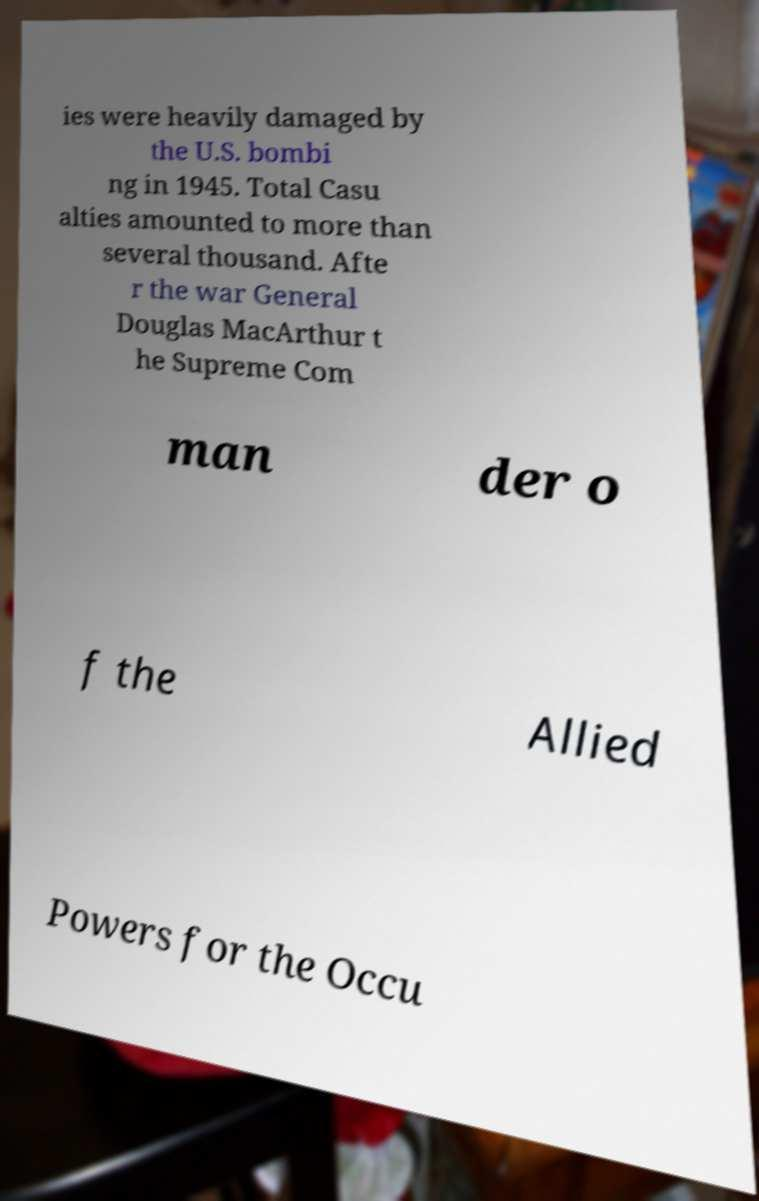For documentation purposes, I need the text within this image transcribed. Could you provide that? ies were heavily damaged by the U.S. bombi ng in 1945. Total Casu alties amounted to more than several thousand. Afte r the war General Douglas MacArthur t he Supreme Com man der o f the Allied Powers for the Occu 